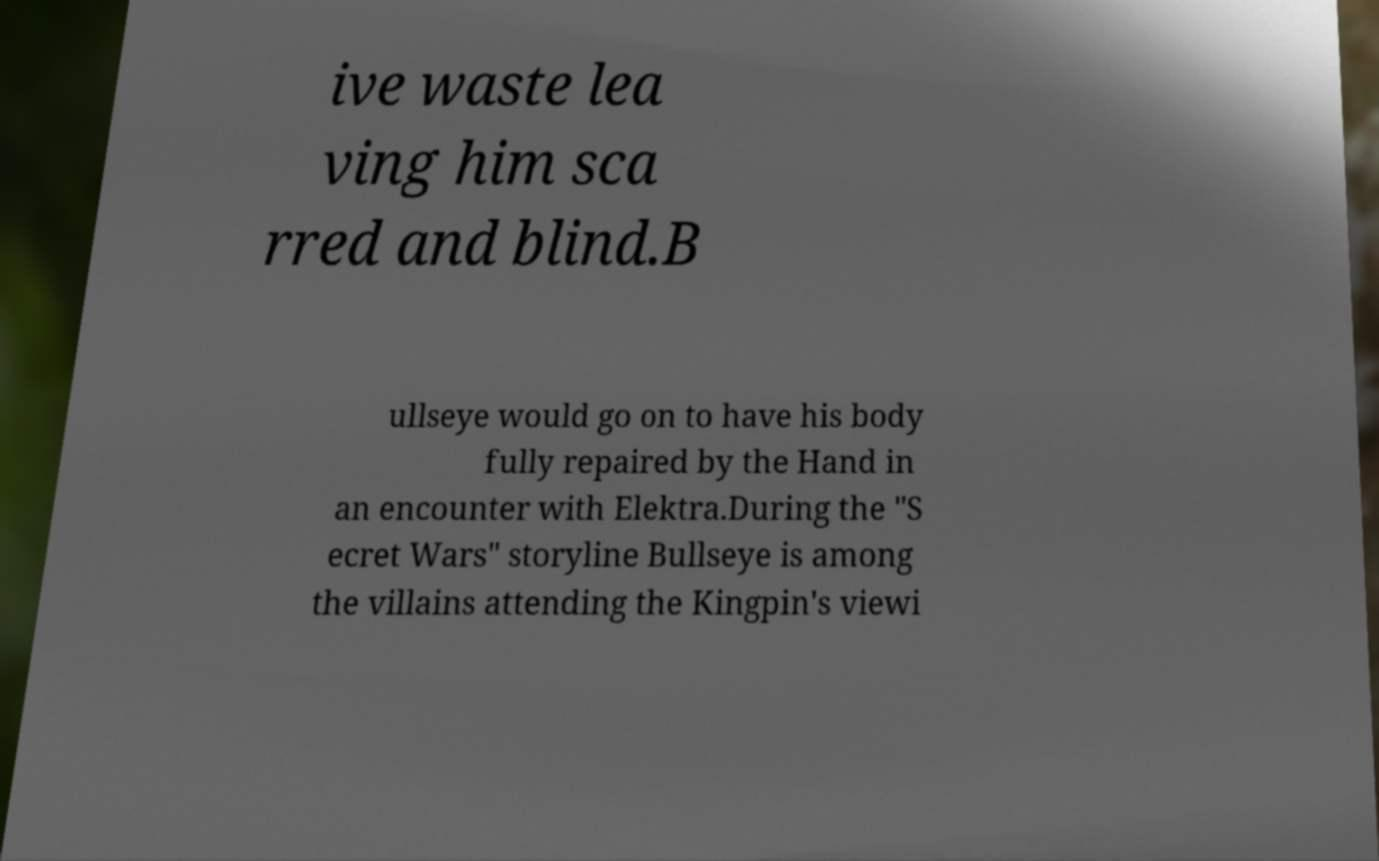Can you read and provide the text displayed in the image?This photo seems to have some interesting text. Can you extract and type it out for me? ive waste lea ving him sca rred and blind.B ullseye would go on to have his body fully repaired by the Hand in an encounter with Elektra.During the "S ecret Wars" storyline Bullseye is among the villains attending the Kingpin's viewi 